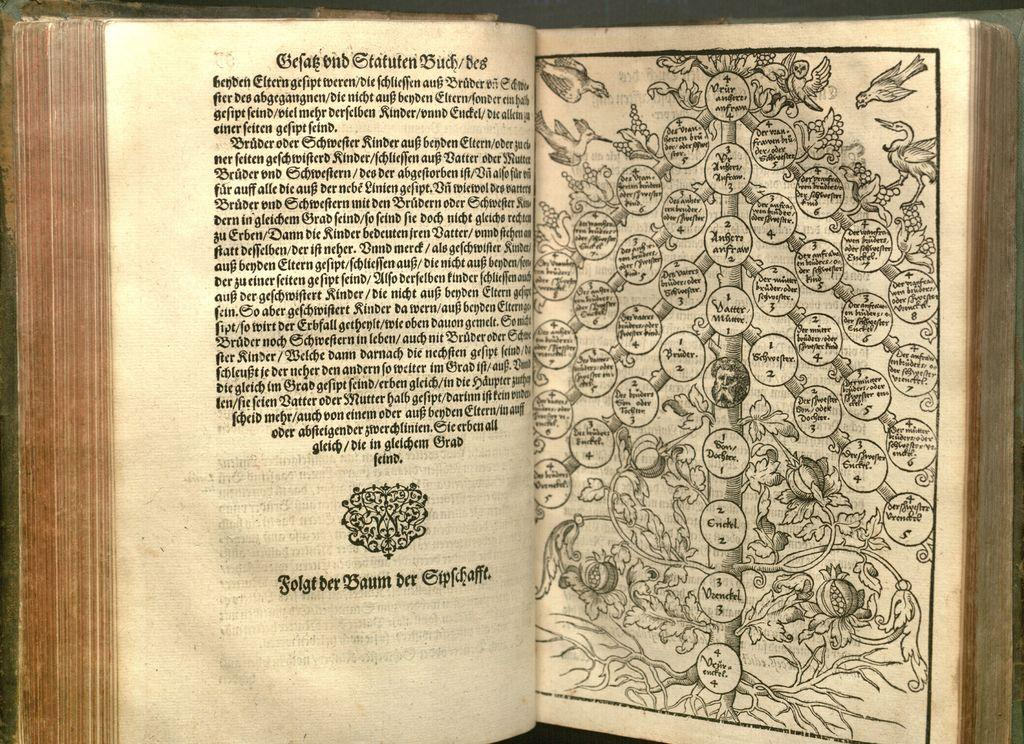<image>
Write a terse but informative summary of the picture. An old book is open to a page that shows a tree with names on it and written in old English says "Gefak and Statuten Buch" on the facing page. 